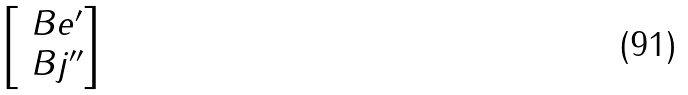<formula> <loc_0><loc_0><loc_500><loc_500>\begin{bmatrix} \ B e ^ { \prime } \\ \ B j ^ { \prime \prime } \end{bmatrix}</formula> 